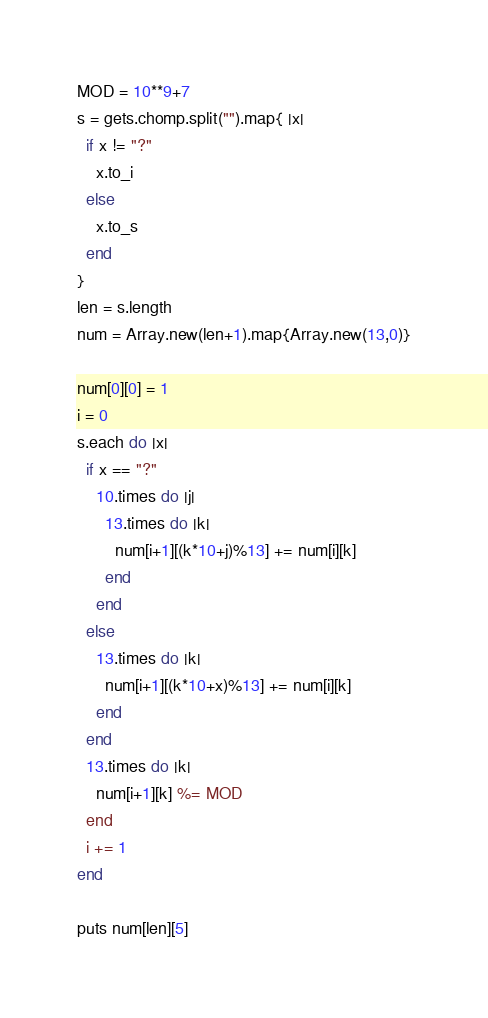Convert code to text. <code><loc_0><loc_0><loc_500><loc_500><_Ruby_>MOD = 10**9+7
s = gets.chomp.split("").map{ |x|
  if x != "?"
    x.to_i
  else
    x.to_s
  end
}
len = s.length
num = Array.new(len+1).map{Array.new(13,0)}

num[0][0] = 1
i = 0
s.each do |x|
  if x == "?"
    10.times do |j|
      13.times do |k|
        num[i+1][(k*10+j)%13] += num[i][k]
      end
    end
  else
    13.times do |k|
      num[i+1][(k*10+x)%13] += num[i][k]
    end
  end
  13.times do |k|
    num[i+1][k] %= MOD
  end
  i += 1
end

puts num[len][5]</code> 